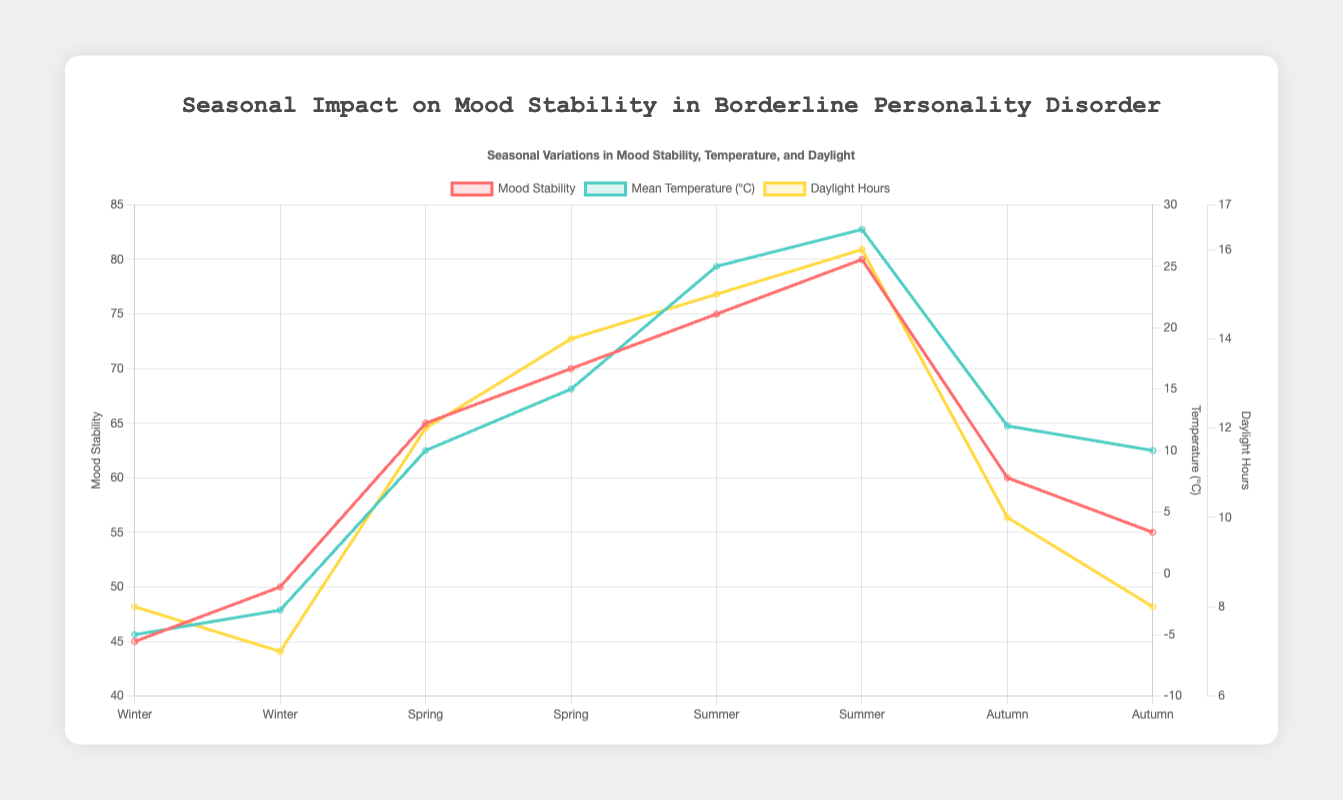What's the highest mood stability value recorded, and in which season does it occur? The highest mood stability value can be found by looking at the "Mood Stability" data points. It is 80. By checking the season associated with this value, we see it occurs in the summer.
Answer: 80, Summer What is the average mood stability during Winter? The mood stability values in Winter are 45 and 50. Adding these together gives 95, and dividing by 2 (the number of data points) results in an average of 47.5.
Answer: 47.5 During which season is there the most discrepancy in the mood stability readings? To find the most discrepancy, calculate the difference between the maximum and minimum mood stability in each season. For Winter: 50 - 45 = 5; Spring: 70 - 65 = 5; Summer: 80 - 75 = 5; Autumn: 60 - 55 = 5. The discrepancy is the same across all seasons.
Answer: Winter, Spring, Summer, and Autumn (all equal) Which season shows the highest mean temperature, and what is its value? Looking at the mean temperature data points, the highest value is 28°C, found in Summer.
Answer: Summer, 28°C Comparing Spring and Autumn, which has greater average daylight hours, and by how much? Calculate the average daylight hours for Spring (12 + 14) / 2 = 13 and for Autumn (10 + 8) / 2 = 9. The difference is 13 - 9 = 4.
Answer: Spring, 4 hours In which season do we see the highest amount of sunlight compared to precipitation? The ratio of daylight hours to precipitation mm can be compared. The highest ratio occurs in Summer with values: 15/30 = 0.5 and 16/25 = 0.64. Therefore, Summer has the highest ratio based on these calculations.
Answer: Summer What is the relationship between temperature and mood stability across seasons? As temperature increases, mood stability also increases, evident from Winter having low temperatures and lower mood stability compared to Summer, which has high temperatures and higher mood stability.
Answer: Positive correlation By how many points does mood stability improve from Winter to Summer? The average mood stability in Winter is 47.5 and in Summer is 77.5. The difference is 77.5 - 47.5 = 30.
Answer: 30 points Which dataset has more impact on mood stability: daytime hours or temperature? Visually, both daylight hours and temperature increase with mood stability, but since mood stability values correlate more closely with temperature changes (low in Winter and high in Summer), temperature seems to have a more direct impact.
Answer: Temperature 